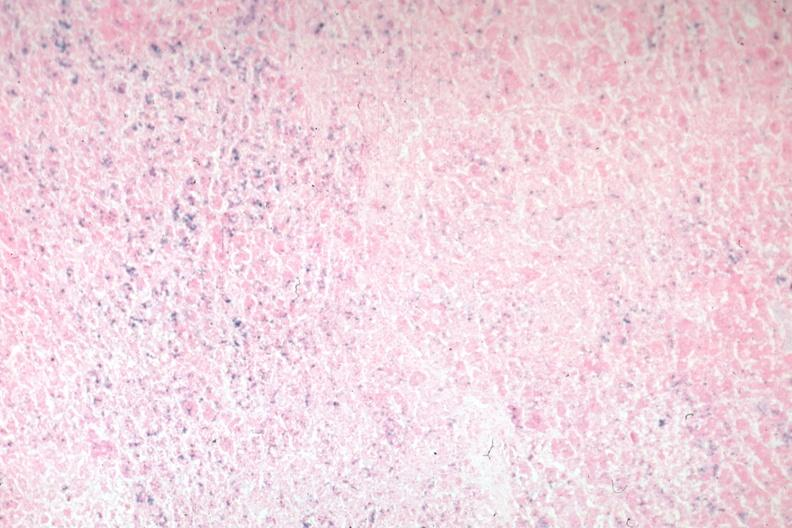what stain?
Answer the question using a single word or phrase. Iron 